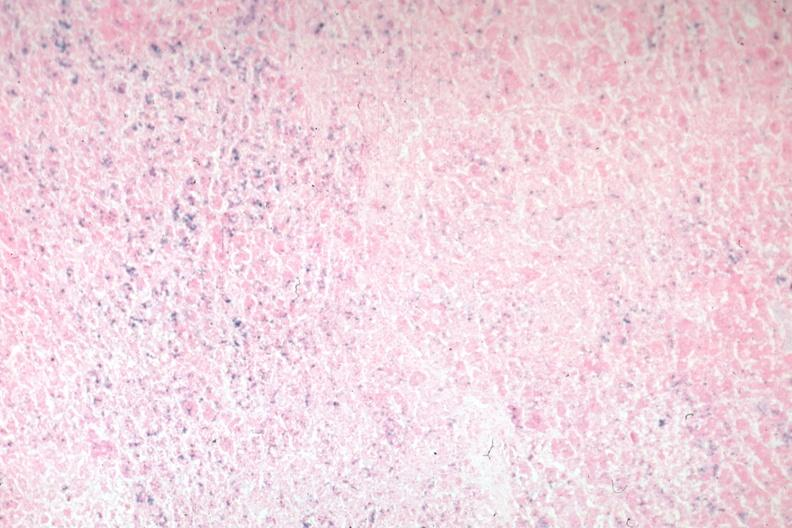what stain?
Answer the question using a single word or phrase. Iron 